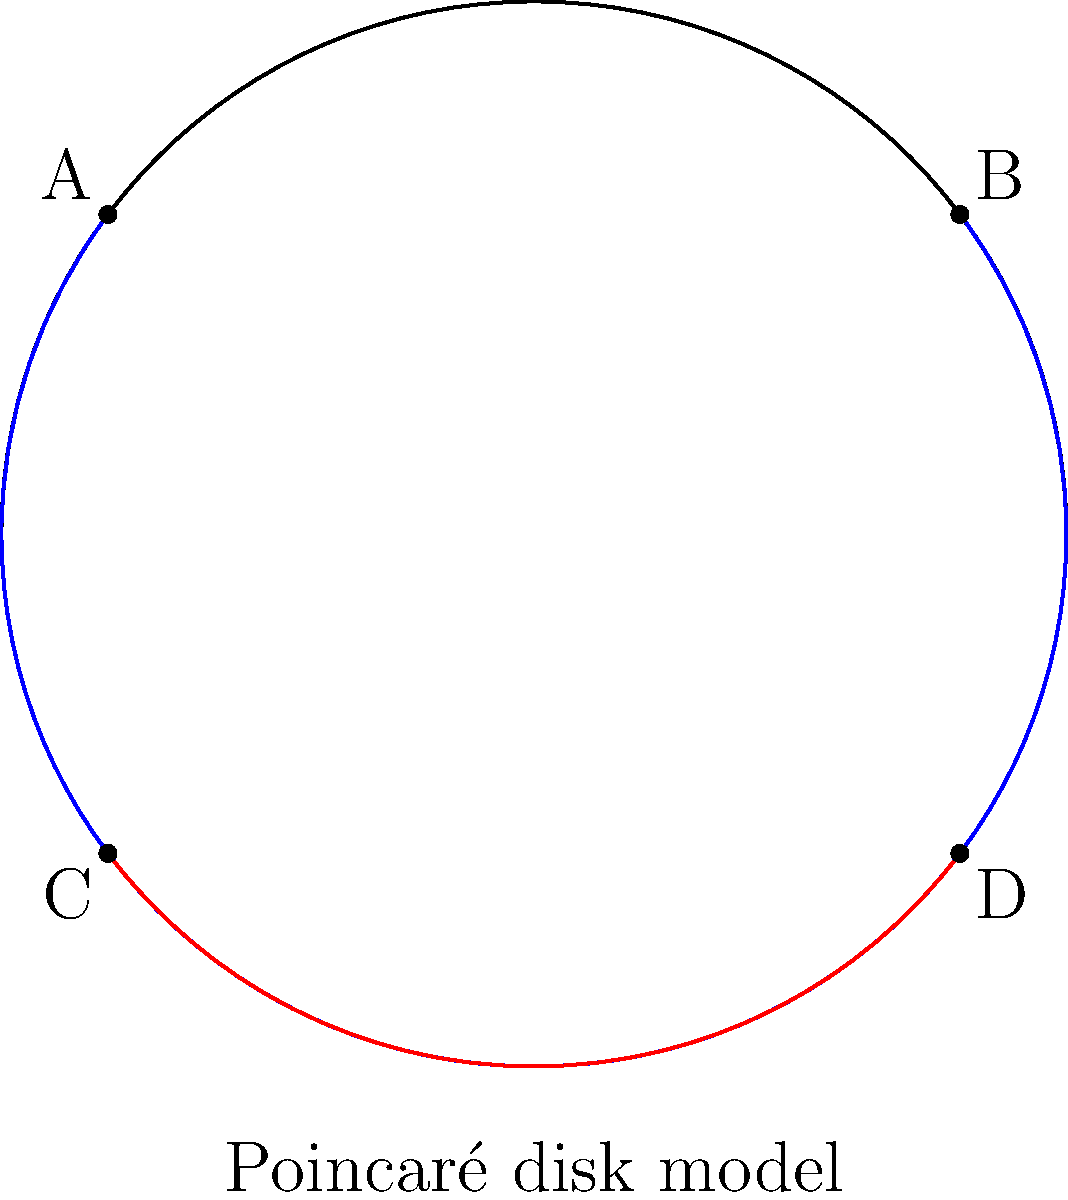In the Poincaré disk model of hyperbolic geometry shown above, two lines (blue and red) are drawn. According to Euclidean geometry, these lines appear curved and intersecting. However, in hyperbolic geometry, they are actually parallel. What property of hyperbolic geometry allows for this seemingly contradictory situation? To understand this situation, let's break it down step-by-step:

1. The Poincaré disk model is a representation of hyperbolic geometry within a Euclidean disk.

2. In this model, "straight" lines in hyperbolic space are represented by:
   a) Arcs of circles that intersect the boundary circle perpendicularly
   b) Diameters of the boundary circle

3. The blue and red arcs in the diagram are examples of "straight" lines in hyperbolic geometry.

4. In hyperbolic geometry, parallel lines are defined as lines that never intersect, even when extended indefinitely.

5. The key property that allows for this situation is the curvature of hyperbolic space:
   - Hyperbolic space has constant negative curvature
   - This curvature causes parallel lines to "bend away" from each other

6. In the Poincaré disk model:
   - The further you get from the center, the more distorted distances become
   - Points near the edge of the disk are actually infinitely far apart in hyperbolic space

7. The blue and red lines in the diagram:
   - Appear to intersect near the edge of the disk in the Euclidean representation
   - Actually diverge and never meet in hyperbolic space

8. This divergence is due to the negative curvature of hyperbolic space, which is not immediately apparent in the Euclidean representation.

In summary, the constant negative curvature of hyperbolic space allows for parallel lines to appear intersecting in Euclidean representations while remaining non-intersecting in hyperbolic space.
Answer: Constant negative curvature of hyperbolic space 